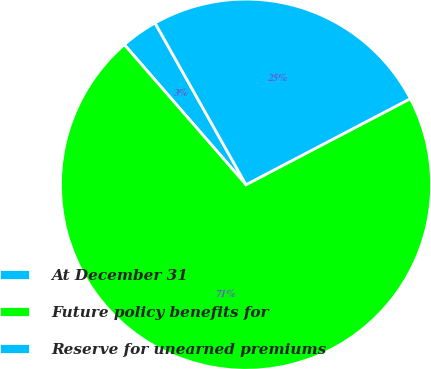<chart> <loc_0><loc_0><loc_500><loc_500><pie_chart><fcel>At December 31<fcel>Future policy benefits for<fcel>Reserve for unearned premiums<nl><fcel>3.23%<fcel>71.29%<fcel>25.48%<nl></chart> 